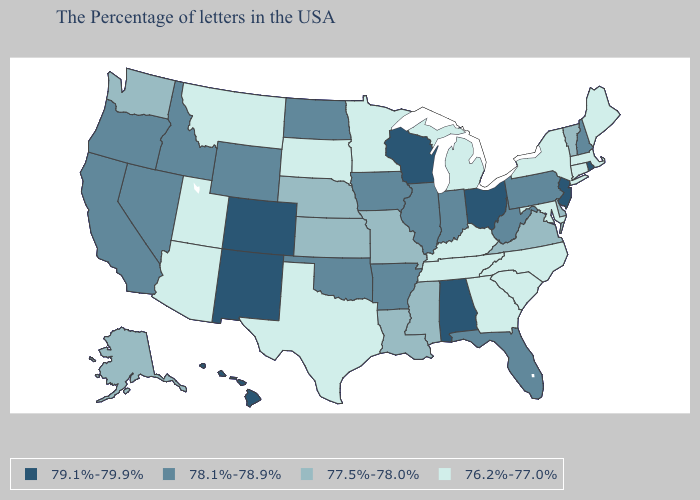Name the states that have a value in the range 79.1%-79.9%?
Keep it brief. Rhode Island, New Jersey, Ohio, Alabama, Wisconsin, Colorado, New Mexico, Hawaii. Does New Jersey have the lowest value in the Northeast?
Quick response, please. No. What is the value of New Hampshire?
Give a very brief answer. 78.1%-78.9%. Name the states that have a value in the range 79.1%-79.9%?
Be succinct. Rhode Island, New Jersey, Ohio, Alabama, Wisconsin, Colorado, New Mexico, Hawaii. Name the states that have a value in the range 76.2%-77.0%?
Quick response, please. Maine, Massachusetts, Connecticut, New York, Maryland, North Carolina, South Carolina, Georgia, Michigan, Kentucky, Tennessee, Minnesota, Texas, South Dakota, Utah, Montana, Arizona. Name the states that have a value in the range 78.1%-78.9%?
Write a very short answer. New Hampshire, Pennsylvania, West Virginia, Florida, Indiana, Illinois, Arkansas, Iowa, Oklahoma, North Dakota, Wyoming, Idaho, Nevada, California, Oregon. What is the highest value in the Northeast ?
Quick response, please. 79.1%-79.9%. How many symbols are there in the legend?
Be succinct. 4. What is the lowest value in the USA?
Quick response, please. 76.2%-77.0%. Among the states that border Arizona , does Colorado have the lowest value?
Quick response, please. No. Does Georgia have a lower value than South Carolina?
Quick response, please. No. Does New Hampshire have the lowest value in the Northeast?
Concise answer only. No. What is the value of Ohio?
Short answer required. 79.1%-79.9%. Name the states that have a value in the range 79.1%-79.9%?
Write a very short answer. Rhode Island, New Jersey, Ohio, Alabama, Wisconsin, Colorado, New Mexico, Hawaii. 